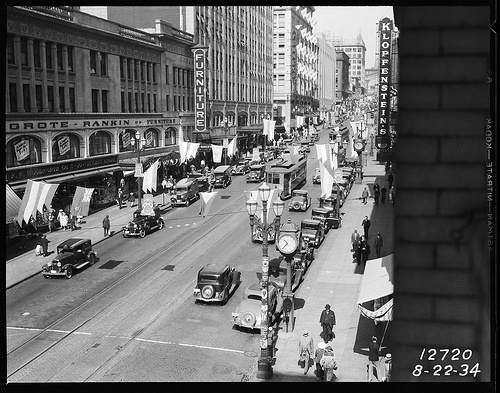Describe the objects in this image and their specific colors. I can see people in black, gray, darkgray, and lightgray tones, car in black, darkgray, gray, and lightgray tones, car in black, darkgray, gray, and lightgray tones, car in black, gray, darkgray, and lightgray tones, and bus in black, darkgray, gray, and lightgray tones in this image. 